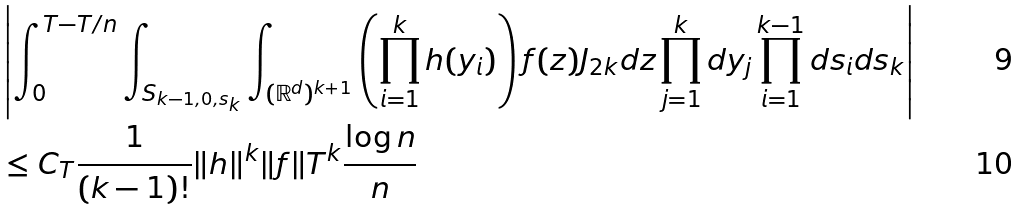Convert formula to latex. <formula><loc_0><loc_0><loc_500><loc_500>& \left | \int _ { 0 } ^ { T - T / n } \int _ { S _ { k - 1 , 0 , s _ { k } } } \int _ { ( \mathbb { R } ^ { d } ) ^ { k + 1 } } \left ( \prod _ { i = 1 } ^ { k } h ( y _ { i } ) \right ) f ( z ) J _ { 2 k } d z \prod _ { j = 1 } ^ { k } d y _ { j } \prod _ { i = 1 } ^ { k - 1 } d s _ { i } d s _ { k } \right | \\ & \leq C _ { T } \frac { 1 } { ( k - 1 ) ! } \| h \| ^ { k } \| f \| T ^ { k } \frac { \log n } { n }</formula> 